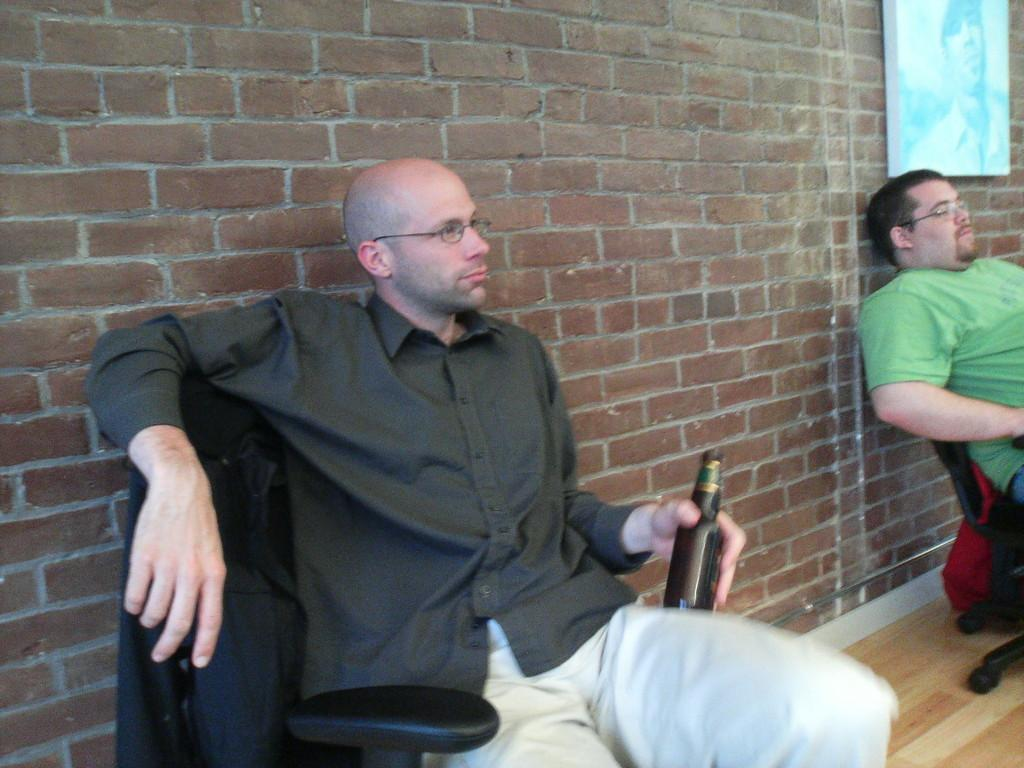How many people are in the image? There are two men in the image. What are the men doing in the image? The men are sitting on a chair. What objects are the men holding in their hands? Each man is holding a glass bottle in his hand. What type of leather material is covering the chair the men are sitting on? The provided facts do not mention any leather material on the chair, so we cannot determine its composition from the image. 